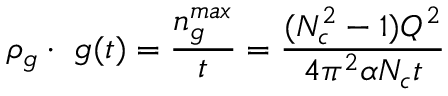Convert formula to latex. <formula><loc_0><loc_0><loc_500><loc_500>\rho _ { g } \cdot \ g ( t ) = { \frac { n _ { g } ^ { \max } } { t } } = { \frac { ( N _ { c } ^ { 2 } - 1 ) Q ^ { 2 } } { 4 \pi ^ { 2 } \alpha N _ { c } t } }</formula> 